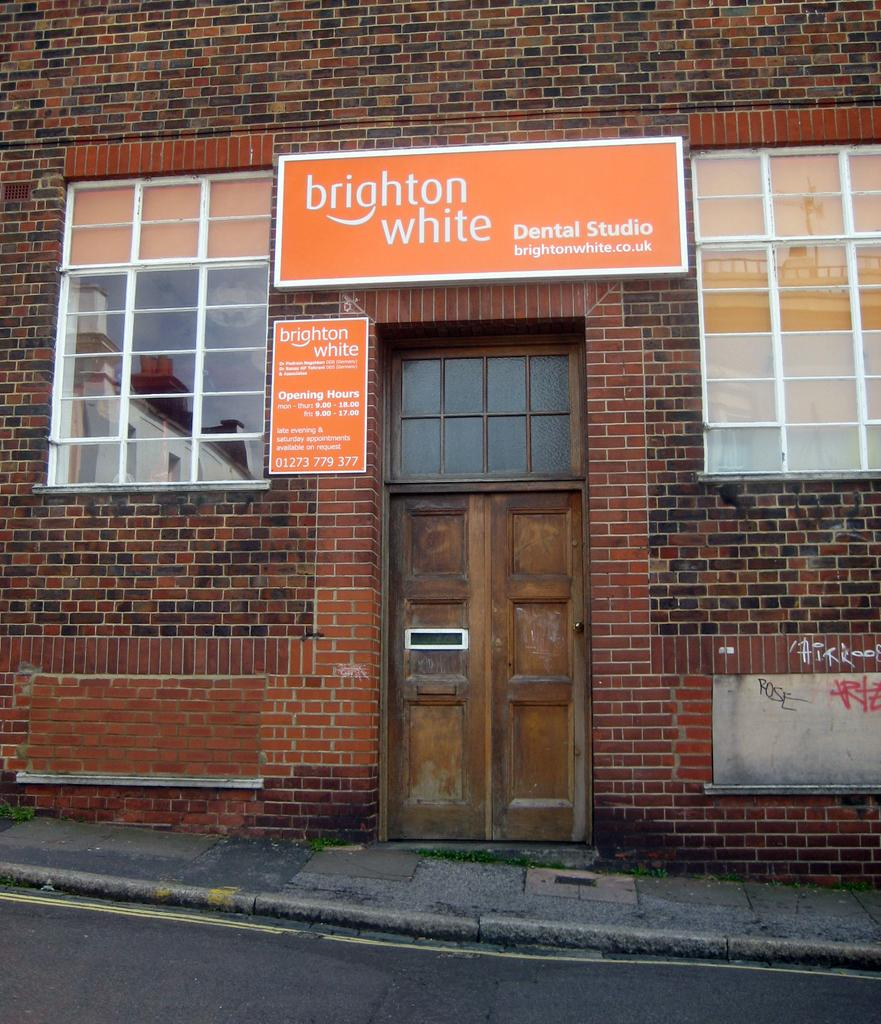What type of structure is visible in the image? There is a house in the image. What materials are covering the house? There are boards on the house. What openings are present on the house? There are windows on the house. How can one enter the house? There is a door on the house. What type of beef is being cooked on the grill in the image? There is no grill or beef present in the image; it only features a house with boards, windows, and a door. 